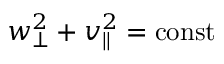<formula> <loc_0><loc_0><loc_500><loc_500>w _ { \perp } ^ { 2 } + v _ { \| } ^ { 2 } = c o n s t</formula> 